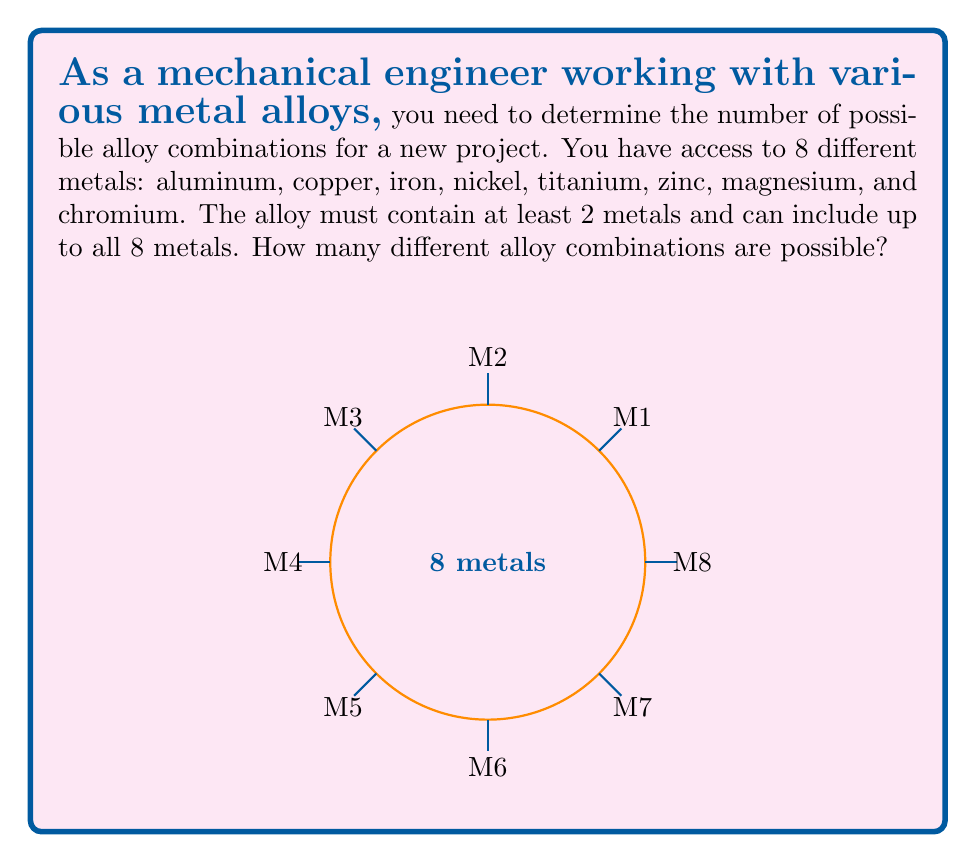Help me with this question. To solve this problem, we need to use the concept of combinations from discrete mathematics. Let's approach this step-by-step:

1) We want to count all possible combinations of metals, where the order doesn't matter (e.g., an alloy of aluminum and copper is the same as copper and aluminum).

2) We need to consider combinations of 2 metals, 3 metals, 4 metals, and so on, up to 8 metals.

3) The number of ways to choose $k$ metals from $n$ metals is given by the combination formula:

   $${n \choose k} = \frac{n!}{k!(n-k)!}$$

4) In our case, $n = 8$ (total number of metals), and $k$ ranges from 2 to 8.

5) We need to sum up all these combinations:

   $$\sum_{k=2}^{8} {8 \choose k}$$

6) Let's calculate each term:
   
   ${8 \choose 2} = 28$
   ${8 \choose 3} = 56$
   ${8 \choose 4} = 70$
   ${8 \choose 5} = 56$
   ${8 \choose 6} = 28$
   ${8 \choose 7} = 8$
   ${8 \choose 8} = 1$

7) Sum up all these values:

   $28 + 56 + 70 + 56 + 28 + 8 + 1 = 247$

Therefore, there are 247 possible alloy combinations.
Answer: 247 